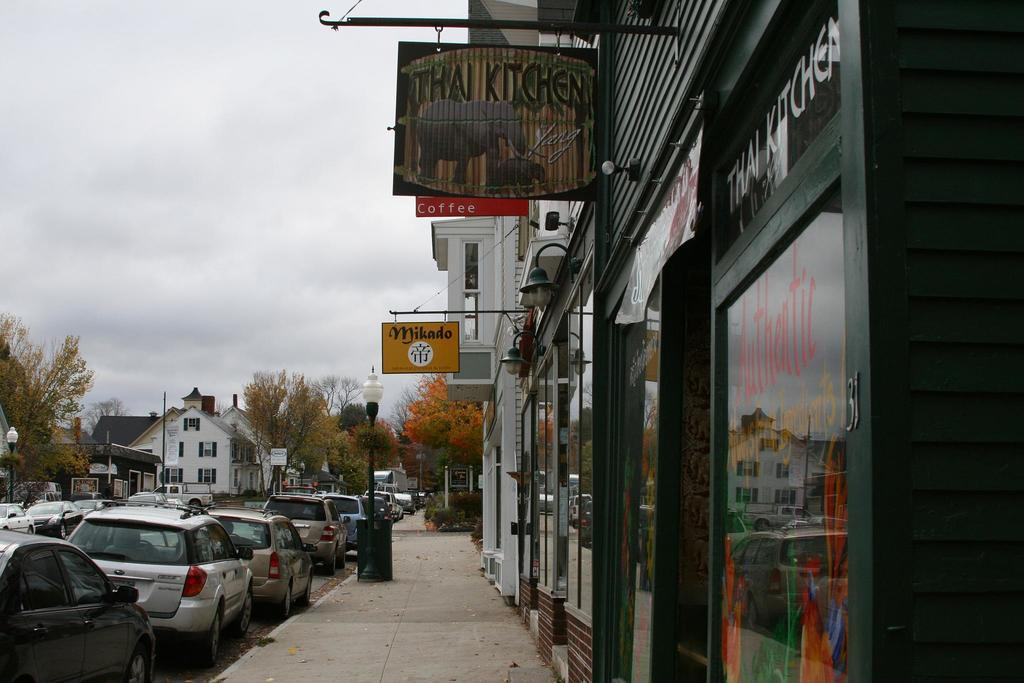What types of structures are visible in the image? There are buildings and houses in the image. Can you describe any specific features of the houses? Some of the houses have boards. What else can be seen in the image besides structures? There are poles, trees, cars, and other vehicles on the road in the image. What color is the sock hanging on the clothesline in the image? There is no sock or clothesline present in the image. How many bits of information can be found on the porter's hat in the image? There is no porter or hat present in the image. 